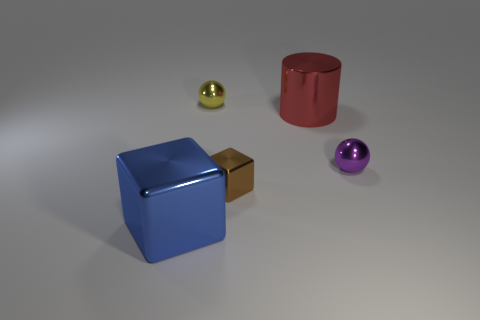Add 4 tiny balls. How many objects exist? 9 Subtract all cylinders. How many objects are left? 4 Add 3 purple objects. How many purple objects are left? 4 Add 1 big purple cylinders. How many big purple cylinders exist? 1 Subtract 1 red cylinders. How many objects are left? 4 Subtract all brown shiny objects. Subtract all gray shiny balls. How many objects are left? 4 